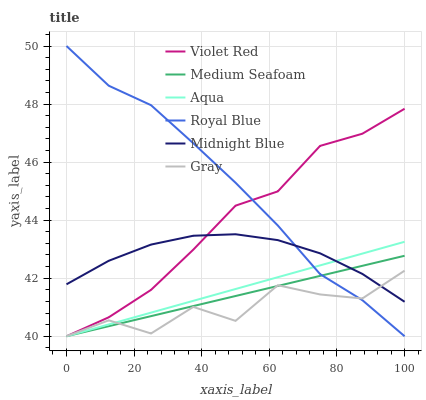Does Gray have the minimum area under the curve?
Answer yes or no. Yes. Does Royal Blue have the maximum area under the curve?
Answer yes or no. Yes. Does Violet Red have the minimum area under the curve?
Answer yes or no. No. Does Violet Red have the maximum area under the curve?
Answer yes or no. No. Is Medium Seafoam the smoothest?
Answer yes or no. Yes. Is Gray the roughest?
Answer yes or no. Yes. Is Violet Red the smoothest?
Answer yes or no. No. Is Violet Red the roughest?
Answer yes or no. No. Does Midnight Blue have the lowest value?
Answer yes or no. No. Does Violet Red have the highest value?
Answer yes or no. No. 